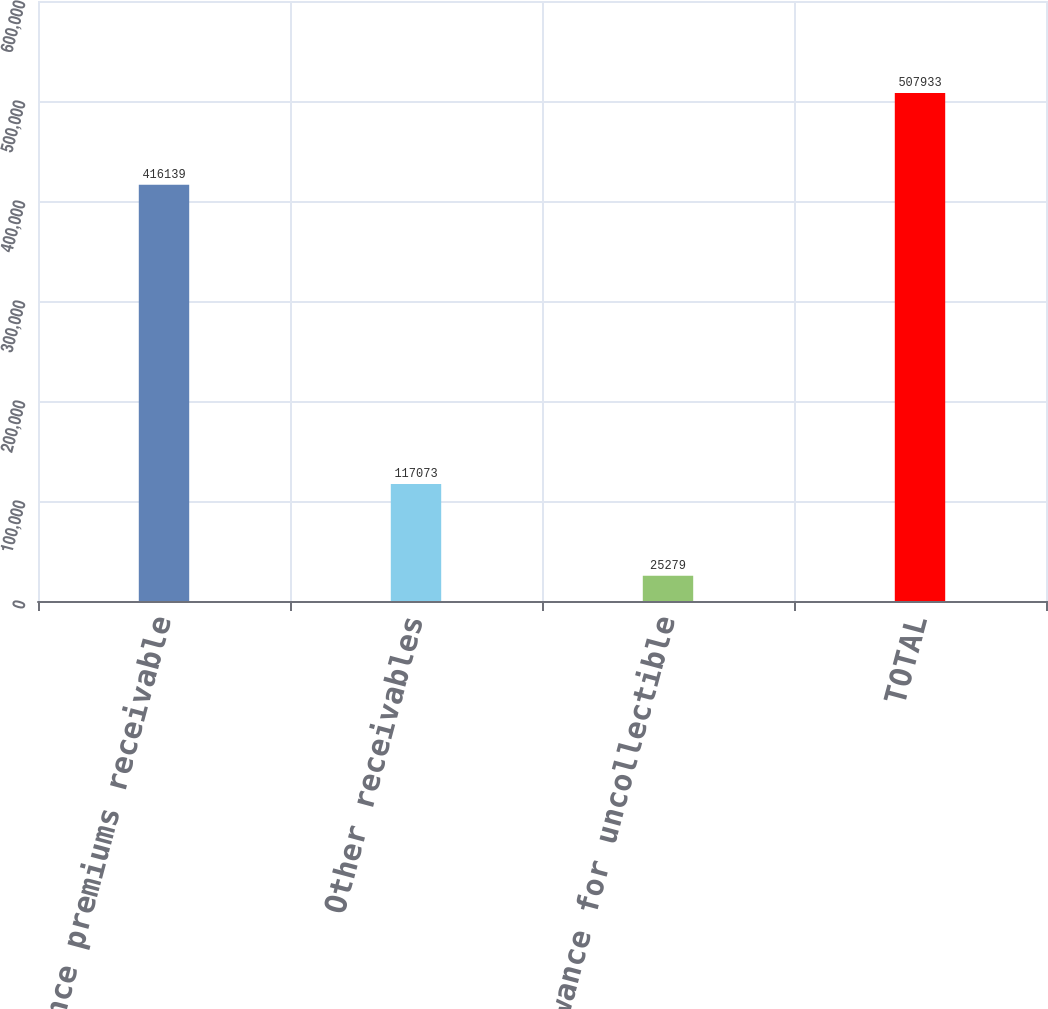Convert chart. <chart><loc_0><loc_0><loc_500><loc_500><bar_chart><fcel>Insurance premiums receivable<fcel>Other receivables<fcel>Allowance for uncollectible<fcel>TOTAL<nl><fcel>416139<fcel>117073<fcel>25279<fcel>507933<nl></chart> 